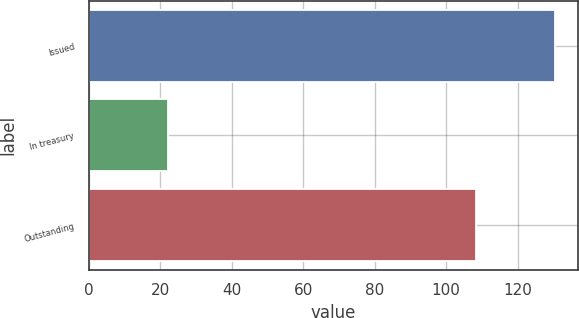Convert chart. <chart><loc_0><loc_0><loc_500><loc_500><bar_chart><fcel>Issued<fcel>In treasury<fcel>Outstanding<nl><fcel>130.3<fcel>22.1<fcel>108.2<nl></chart> 